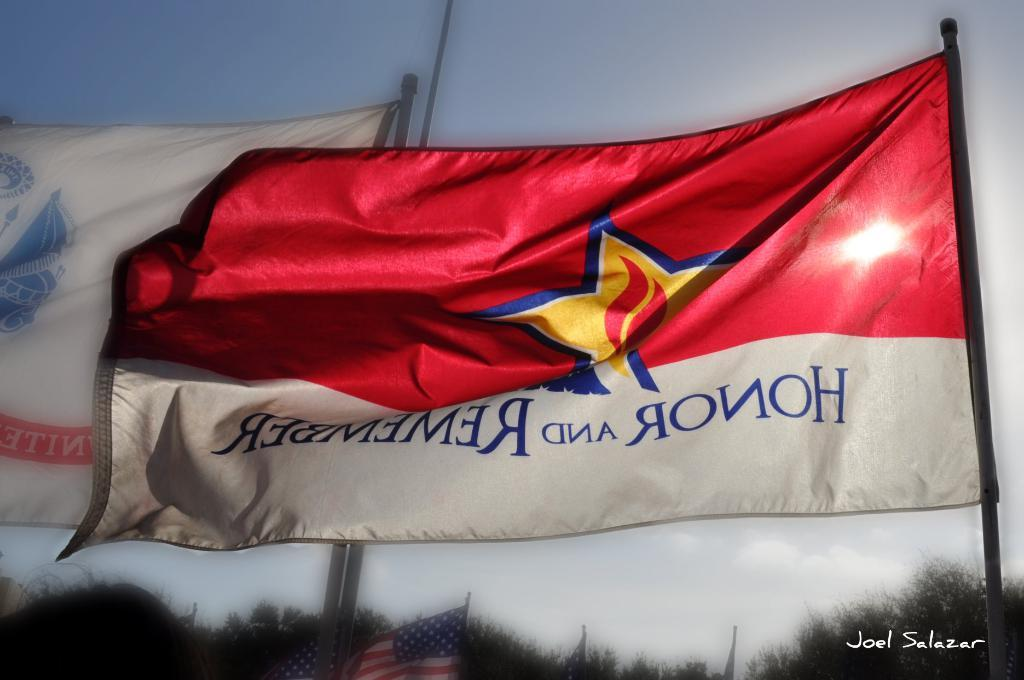What objects with poles can be seen in the image? There are flags with poles in the image. What type of vegetation is at the bottom of the image? There are trees at the bottom of the image. What can be seen in the background of the image? Sky is visible in the background of the image. What is present in the sky? Clouds are present in the sky. Where is the chair located in the image? There is no chair present in the image. What advice does the mom give in the image? There is no mom or advice-giving scene in the image. 